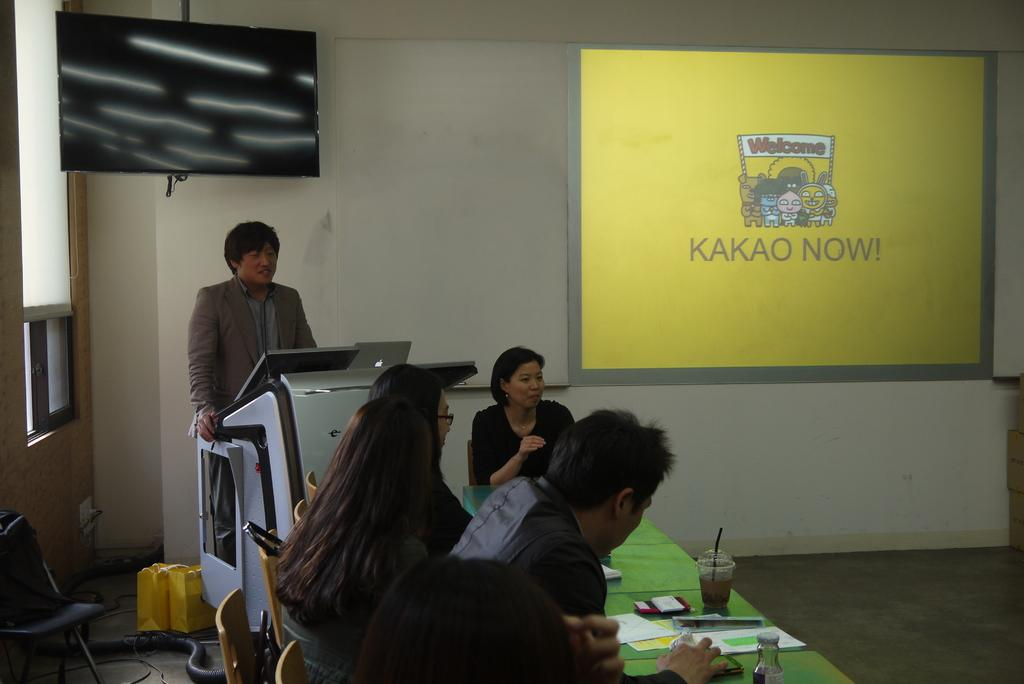<image>
Describe the image concisely. people sit in a lecture room with a screen reading Kakao Now! 